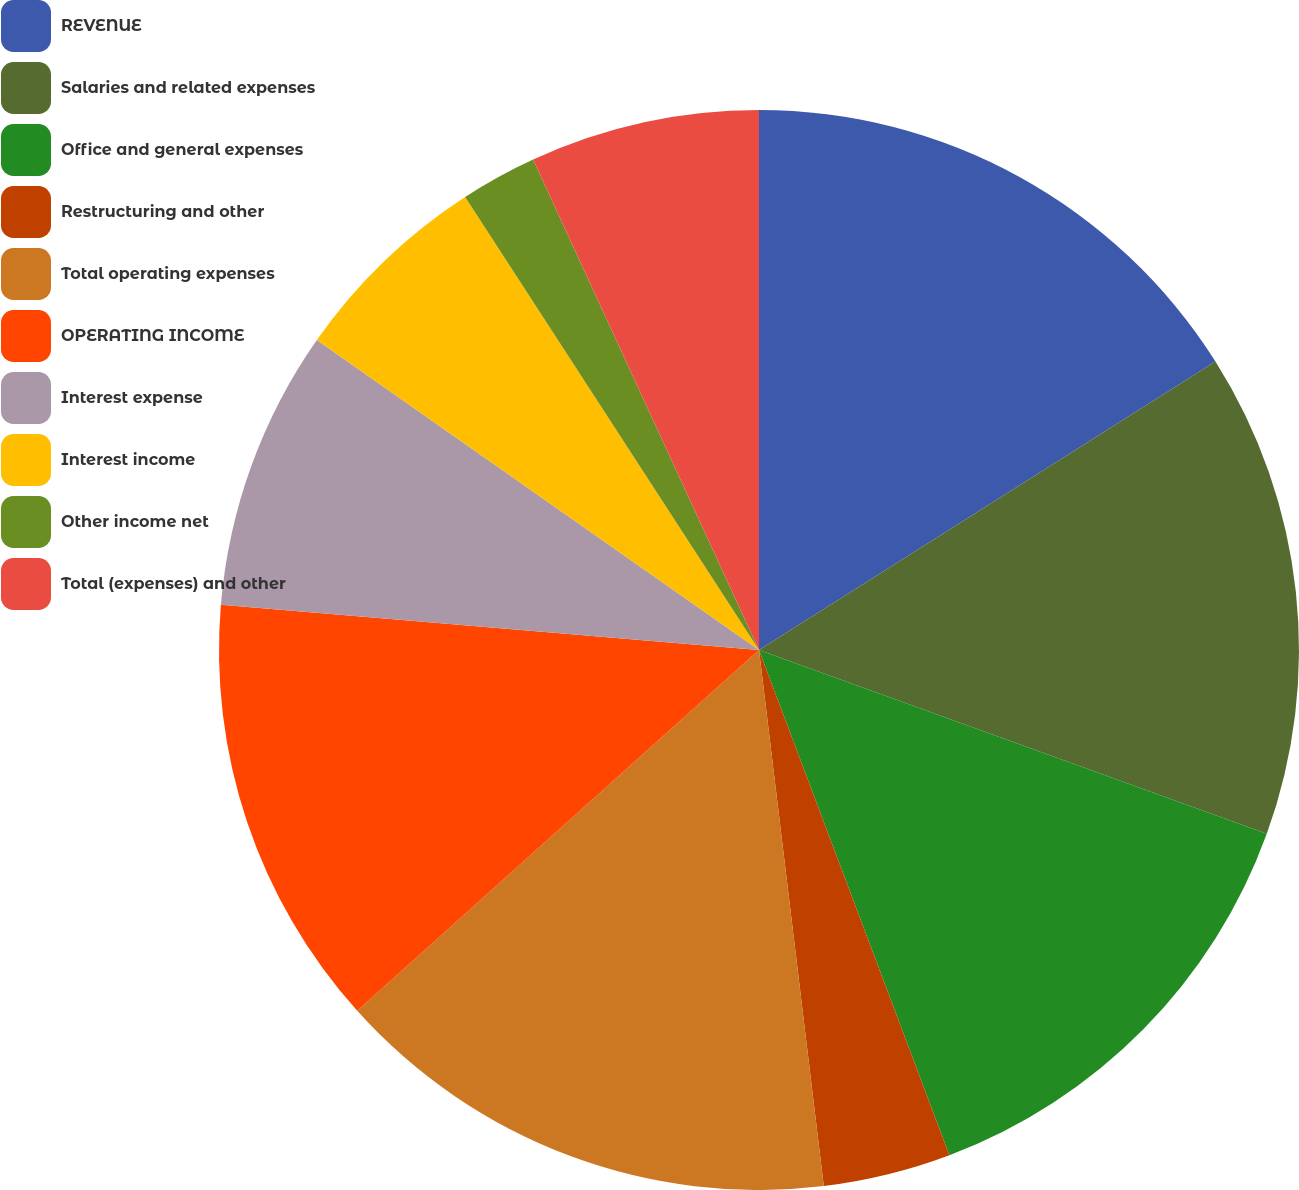<chart> <loc_0><loc_0><loc_500><loc_500><pie_chart><fcel>REVENUE<fcel>Salaries and related expenses<fcel>Office and general expenses<fcel>Restructuring and other<fcel>Total operating expenses<fcel>OPERATING INCOME<fcel>Interest expense<fcel>Interest income<fcel>Other income net<fcel>Total (expenses) and other<nl><fcel>16.03%<fcel>14.5%<fcel>13.74%<fcel>3.82%<fcel>15.27%<fcel>12.98%<fcel>8.4%<fcel>6.11%<fcel>2.29%<fcel>6.87%<nl></chart> 